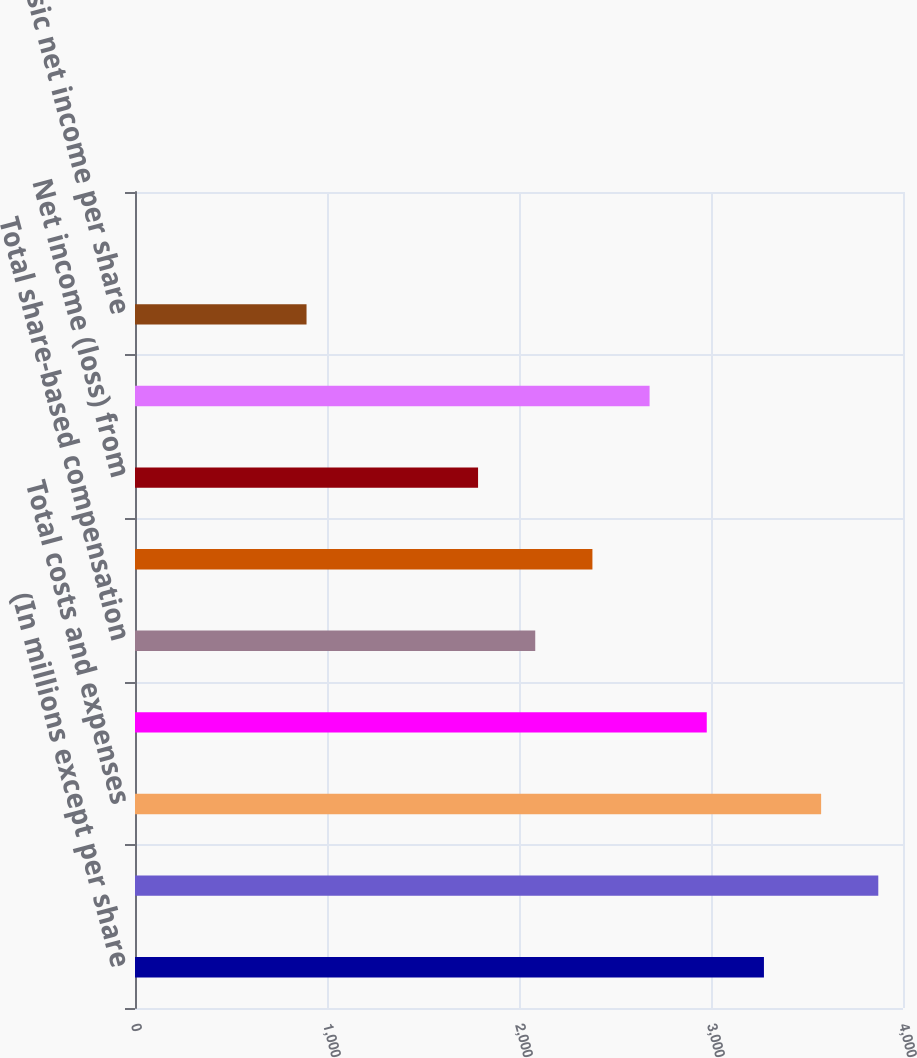Convert chart. <chart><loc_0><loc_0><loc_500><loc_500><bar_chart><fcel>(In millions except per share<fcel>Total net revenue<fcel>Total costs and expenses<fcel>Operating income from<fcel>Total share-based compensation<fcel>Net income from continuing<fcel>Net income (loss) from<fcel>Net income<fcel>Basic net income per share<fcel>Basic net income (loss) per<nl><fcel>3275.75<fcel>3871.33<fcel>3573.54<fcel>2977.96<fcel>2084.59<fcel>2382.38<fcel>1786.8<fcel>2680.17<fcel>893.43<fcel>0.06<nl></chart> 